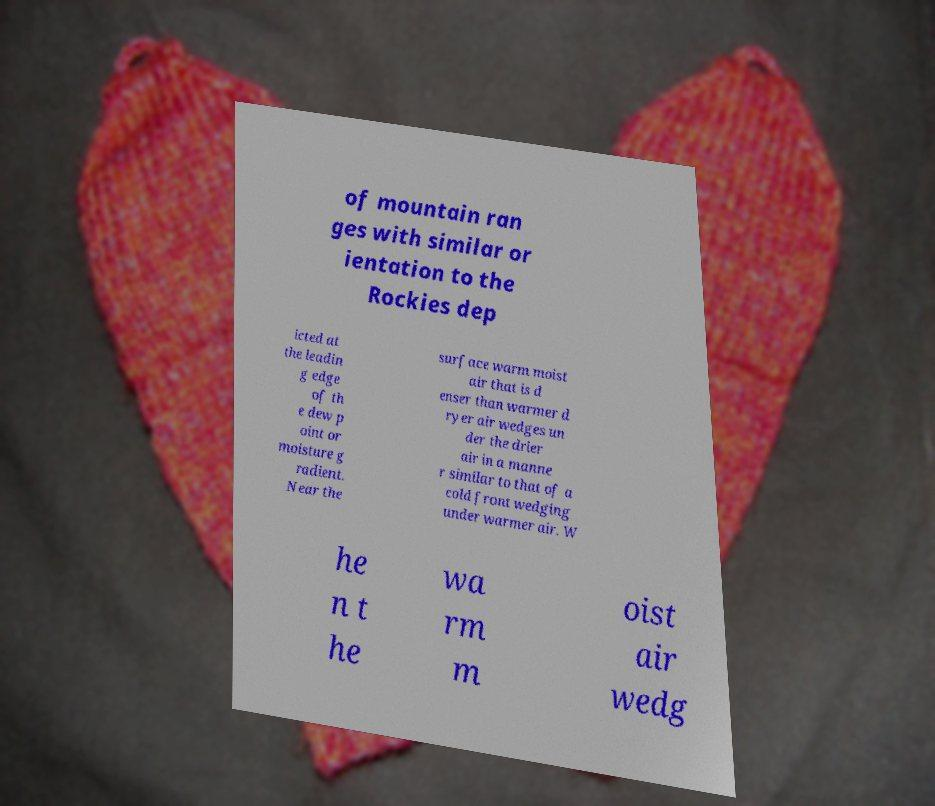Could you extract and type out the text from this image? of mountain ran ges with similar or ientation to the Rockies dep icted at the leadin g edge of th e dew p oint or moisture g radient. Near the surface warm moist air that is d enser than warmer d ryer air wedges un der the drier air in a manne r similar to that of a cold front wedging under warmer air. W he n t he wa rm m oist air wedg 